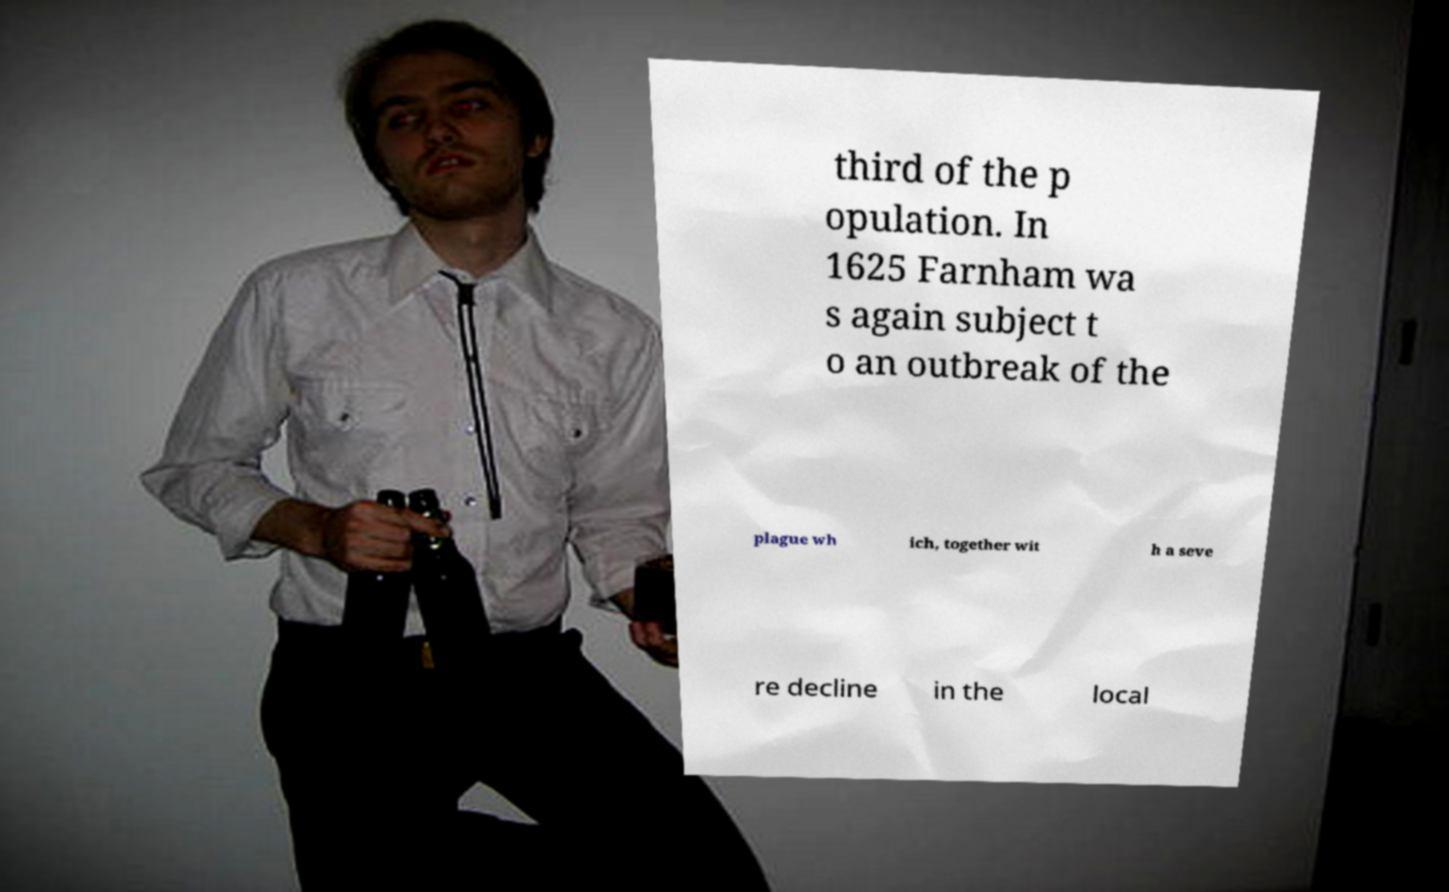For documentation purposes, I need the text within this image transcribed. Could you provide that? third of the p opulation. In 1625 Farnham wa s again subject t o an outbreak of the plague wh ich, together wit h a seve re decline in the local 